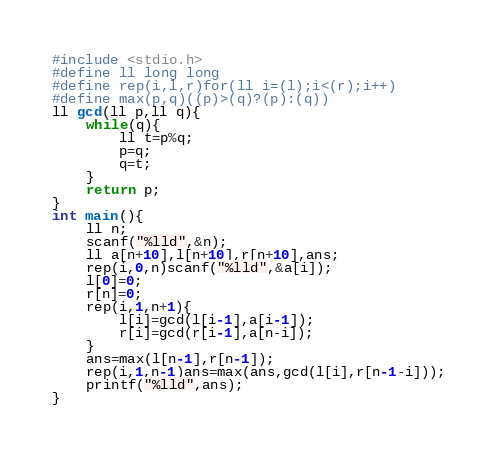<code> <loc_0><loc_0><loc_500><loc_500><_C_>#include <stdio.h>
#define ll long long
#define rep(i,l,r)for(ll i=(l);i<(r);i++)
#define max(p,q)((p)>(q)?(p):(q))
ll gcd(ll p,ll q){
	while(q){
		ll t=p%q;
		p=q;
		q=t;
	}
	return p;
}
int main(){
    ll n;
	scanf("%lld",&n);
    ll a[n+10],l[n+10],r[n+10],ans;
	rep(i,0,n)scanf("%lld",&a[i]);
	l[0]=0;
	r[n]=0;
	rep(i,1,n+1){
		l[i]=gcd(l[i-1],a[i-1]);
		r[i]=gcd(r[i-1],a[n-i]);
	}
	ans=max(l[n-1],r[n-1]);
	rep(i,1,n-1)ans=max(ans,gcd(l[i],r[n-1-i]));
	printf("%lld",ans);
}</code> 